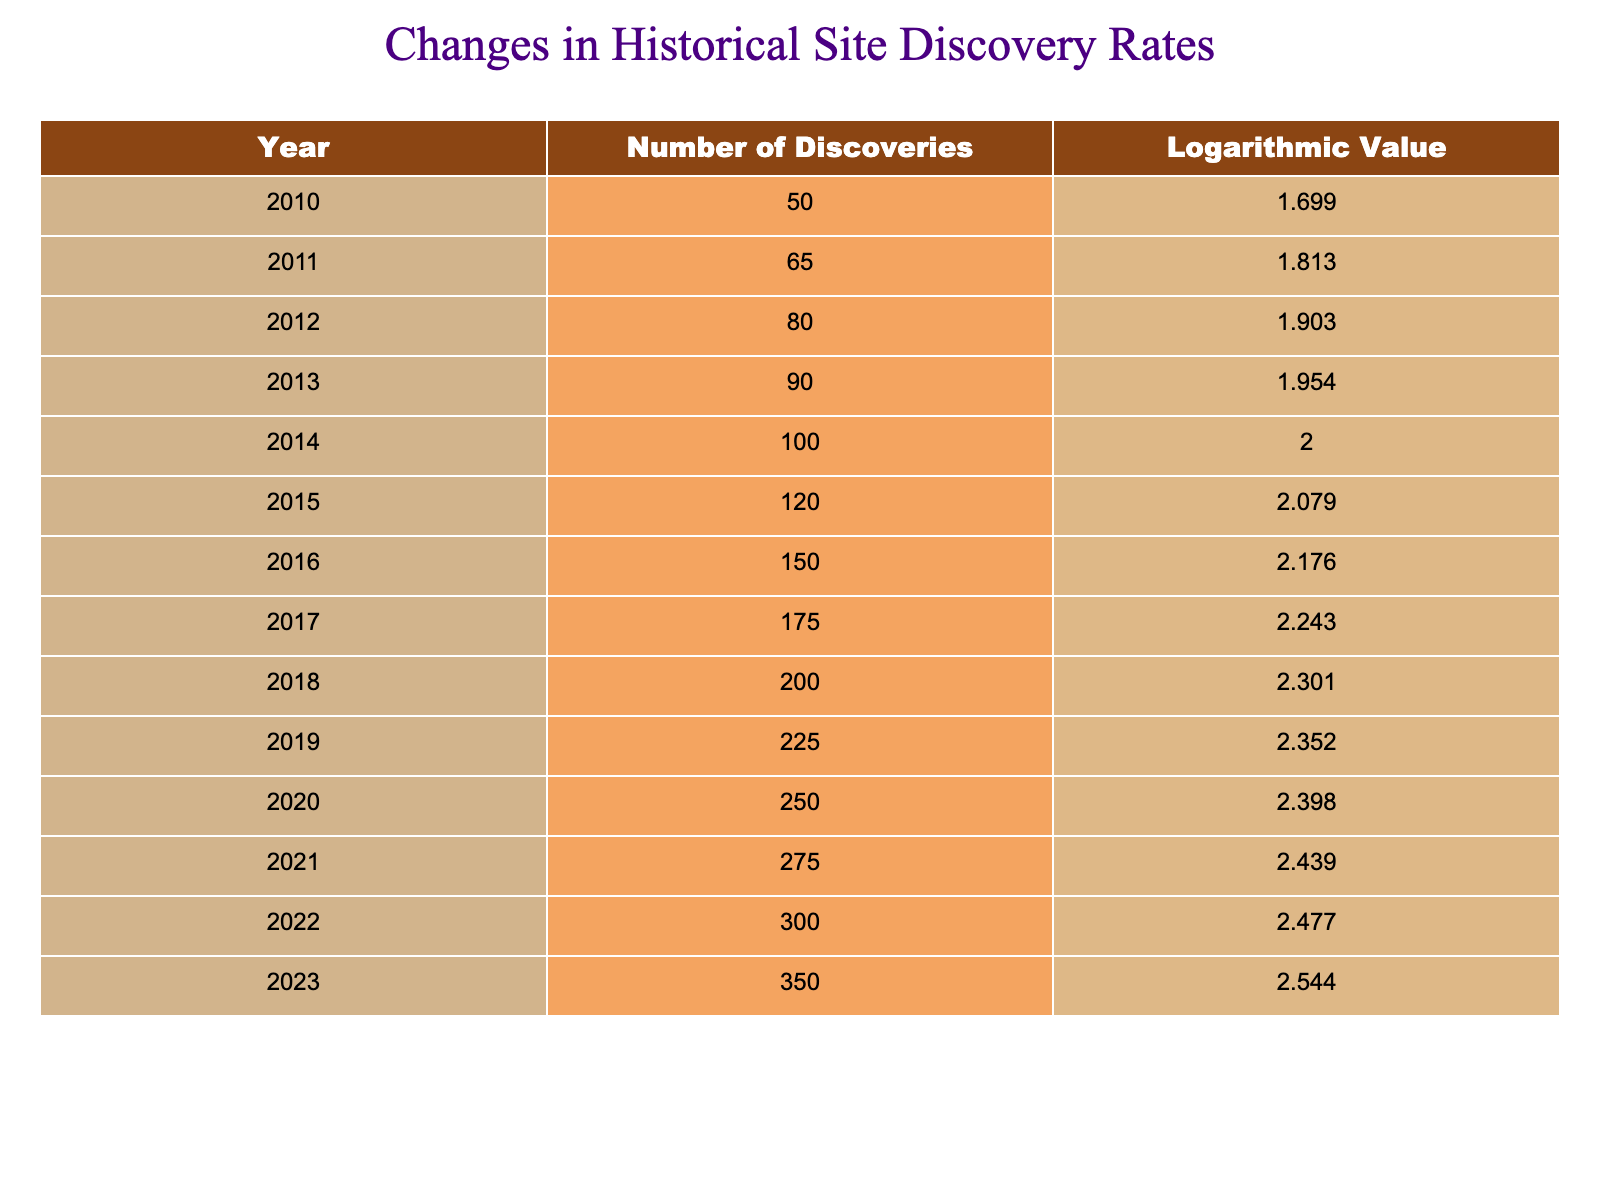What was the rate of discoveries in the year with the highest number? The table shows that the highest number of discoveries occurred in 2023, with a count of 350.
Answer: 350 In which year were there more than 200 discoveries? The table indicates that discoveries exceeded 200 in the years 2018 (200), 2019 (225), 2020 (250), 2021 (275), 2022 (300), and 2023 (350).
Answer: 2018, 2019, 2020, 2021, 2022, 2023 What is the increase in the number of discoveries from 2010 to 2015? The number of discoveries in 2010 was 50, and in 2015 it was 120. The increase is calculated as 120 - 50 = 70.
Answer: 70 Is it true that the logarithmic value for the year with the least discoveries is less than 1.5? The table shows that the logarithmic value for the year 2010, which had the least discoveries (50), is 1.699, which is greater than 1.5.
Answer: No What was the average number of discoveries between 2015 and 2020? To find the average, sum the number of discoveries from 2015 to 2020: 120 (2015) + 150 (2016) + 175 (2017) + 200 (2018) + 225 (2019) + 250 (2020) = 1120. There are 6 years in this range, so the average is 1120 / 6 = 186.67.
Answer: 186.67 What year saw an increase of exactly 50 discoveries from the previous year? Observing the table, from 2019 to 2020, the number of discoveries increased from 225 to 250, which is an increase of exactly 25. Also, from 2018 to 2019, it increased from 200 to 225, which is also an increase of 25. The year with an increase of 50 does not occur in the table, confirming no such year fits this criteria.
Answer: None How many more discoveries were made in 2023 compared to 2012? The number of discoveries in 2023 is 350, and in 2012 it is 80. The difference is 350 - 80 = 270.
Answer: 270 What is the trend in logarithmic values from 2010 to 2023? The logarithmic values show a continuous increase over the years from 2010 (1.699) to 2023 (2.544). This indicates a positive trend in historical site discovery rates over the years.
Answer: Increasing 